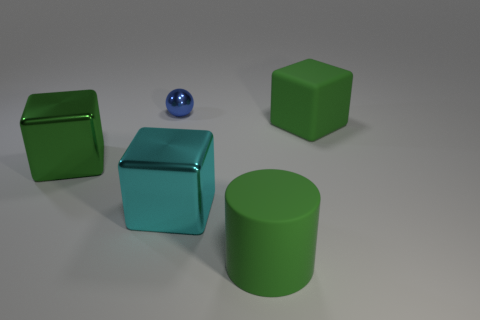There is a cube that is in front of the thing to the left of the tiny ball; how big is it?
Provide a succinct answer. Large. Is the large cube that is to the right of the cyan metal object made of the same material as the cyan block?
Your response must be concise. No. The big green metal thing in front of the shiny sphere has what shape?
Your answer should be very brief. Cube. What number of green metal cubes have the same size as the green rubber cylinder?
Provide a succinct answer. 1. How big is the green rubber block?
Provide a short and direct response. Large. There is a blue metallic ball; what number of big cylinders are in front of it?
Ensure brevity in your answer.  1. There is a small thing that is made of the same material as the big cyan object; what is its shape?
Offer a terse response. Sphere. Is the number of large rubber cubes that are behind the green cylinder less than the number of large green matte cylinders that are behind the small shiny thing?
Ensure brevity in your answer.  No. Are there more cylinders than big gray rubber balls?
Provide a succinct answer. Yes. What is the material of the cyan cube?
Make the answer very short. Metal. 